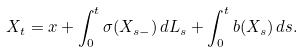<formula> <loc_0><loc_0><loc_500><loc_500>X _ { t } = x + \int _ { 0 } ^ { t } \sigma ( X _ { s - } ) \, d L _ { s } + \int _ { 0 } ^ { t } b ( X _ { s } ) \, d s .</formula> 